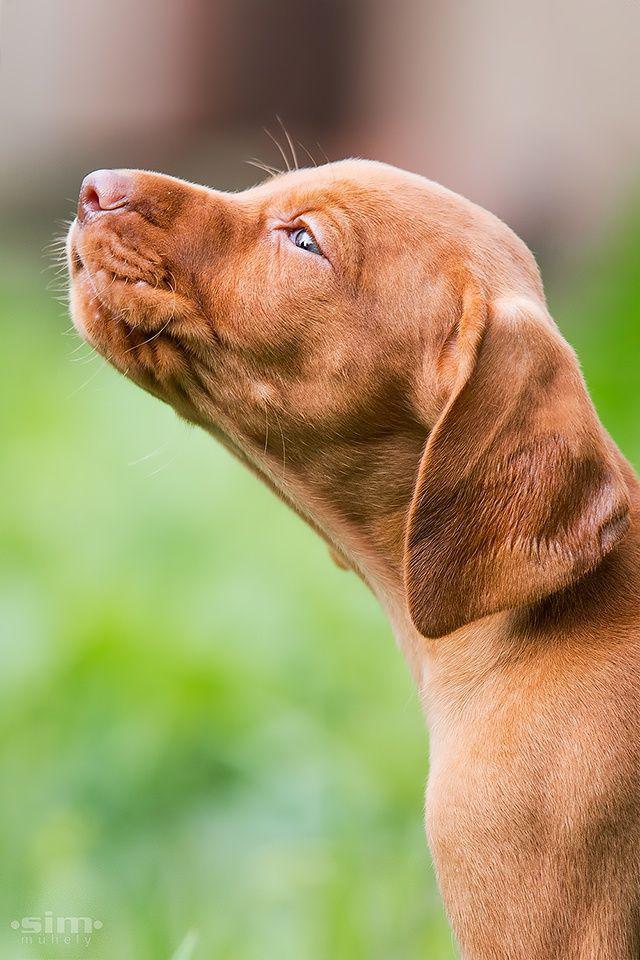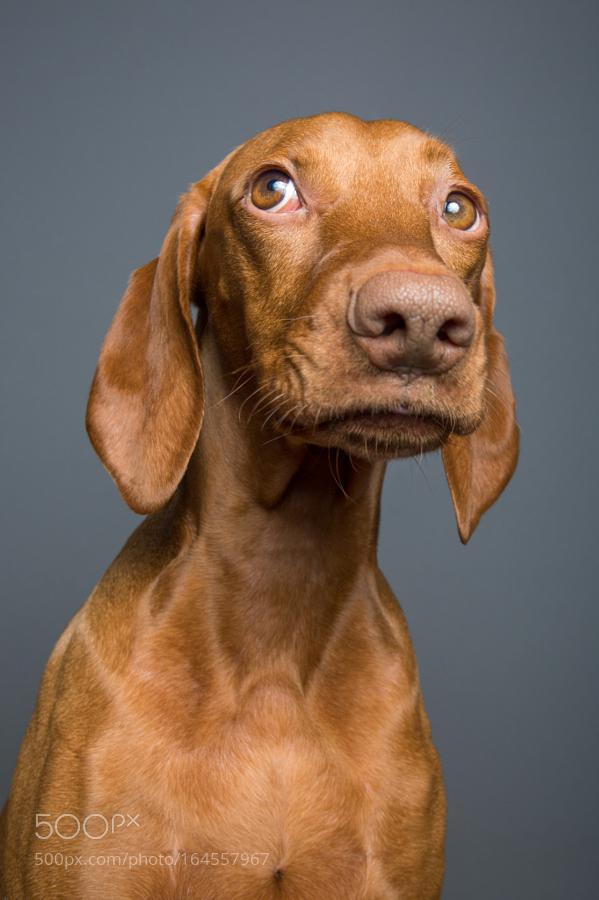The first image is the image on the left, the second image is the image on the right. Considering the images on both sides, is "The dog in one of the images is lying down on the grass." valid? Answer yes or no. No. The first image is the image on the left, the second image is the image on the right. For the images shown, is this caption "At least one dog is outside facing left." true? Answer yes or no. Yes. 